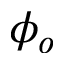<formula> <loc_0><loc_0><loc_500><loc_500>\phi _ { o }</formula> 